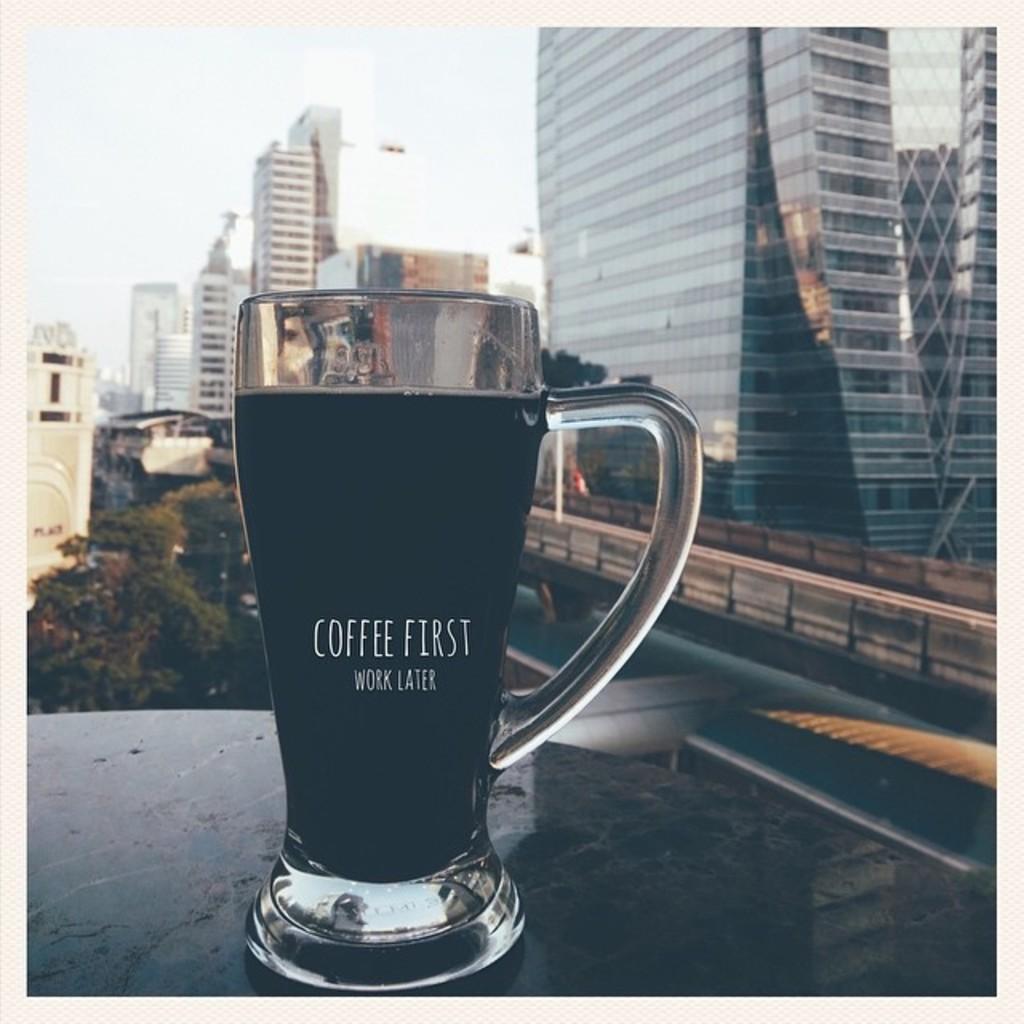Can you describe this image briefly? In the picture I can see a glass with a drink in it and we can see some text on the glass which is placed on the surface. In the background, we can see tower buildings, trees and the sky. 